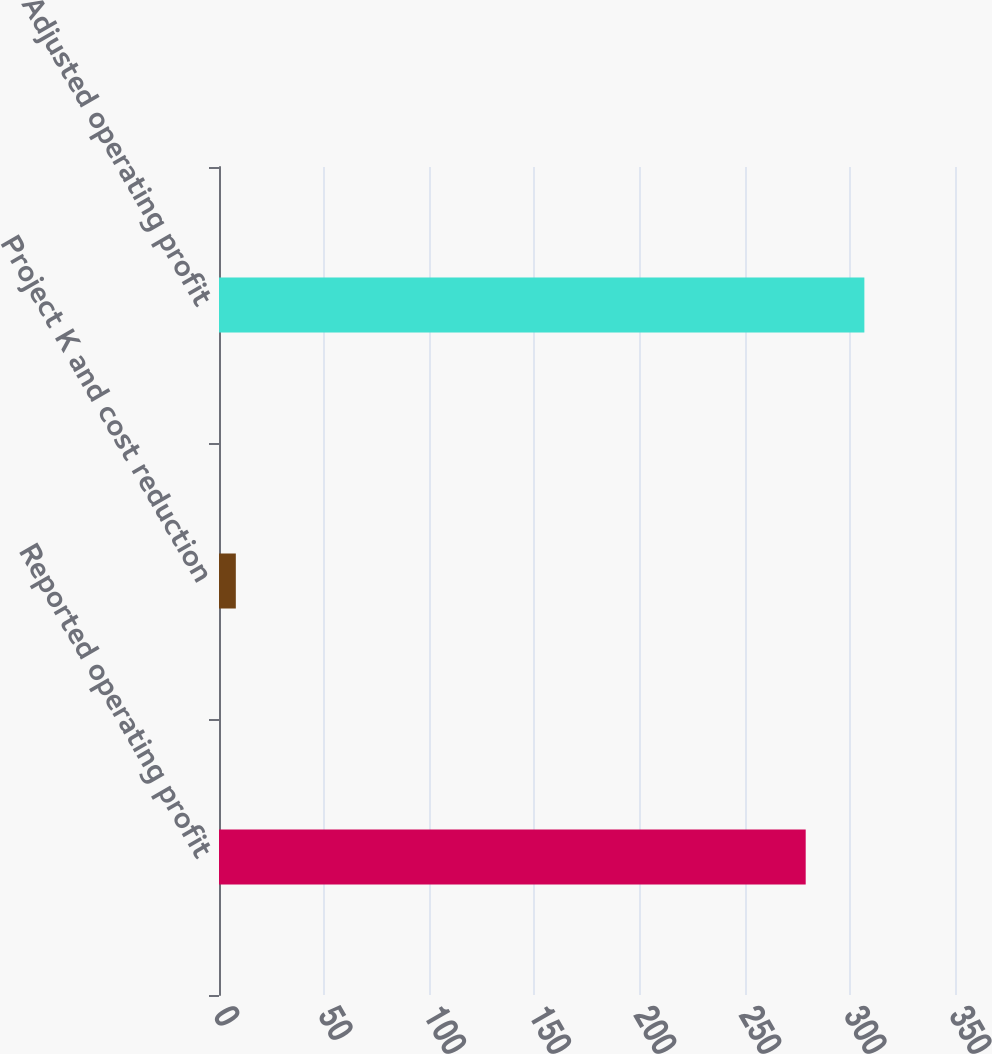Convert chart. <chart><loc_0><loc_0><loc_500><loc_500><bar_chart><fcel>Reported operating profit<fcel>Project K and cost reduction<fcel>Adjusted operating profit<nl><fcel>279<fcel>8<fcel>306.9<nl></chart> 